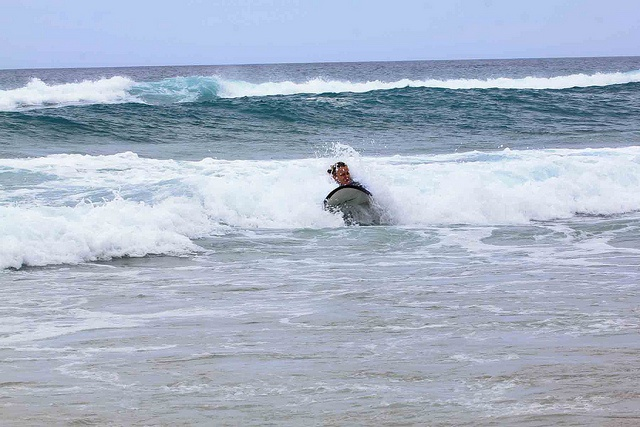Describe the objects in this image and their specific colors. I can see surfboard in lavender, gray, darkgray, and black tones and people in lavender, black, gray, maroon, and brown tones in this image. 